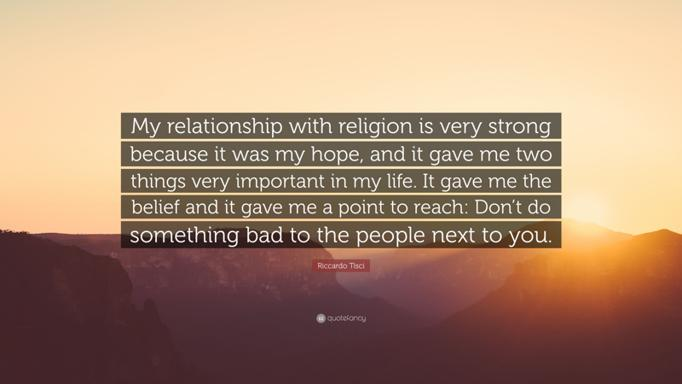What are the two important things the speaker's relationship with religion gave them? The speaker's relationship with religion gave them belief and a point to reach. What advice does the speaker give about interacting with people around them? The speaker advises not to do something bad to the people next to you. What can we infer about Riccardo Tisci from the quote? We can infer that Riccardo Tisci has a strong relationship with religion, which has had a significant positive impact on his life, and he values treating others with kindness and respect. 